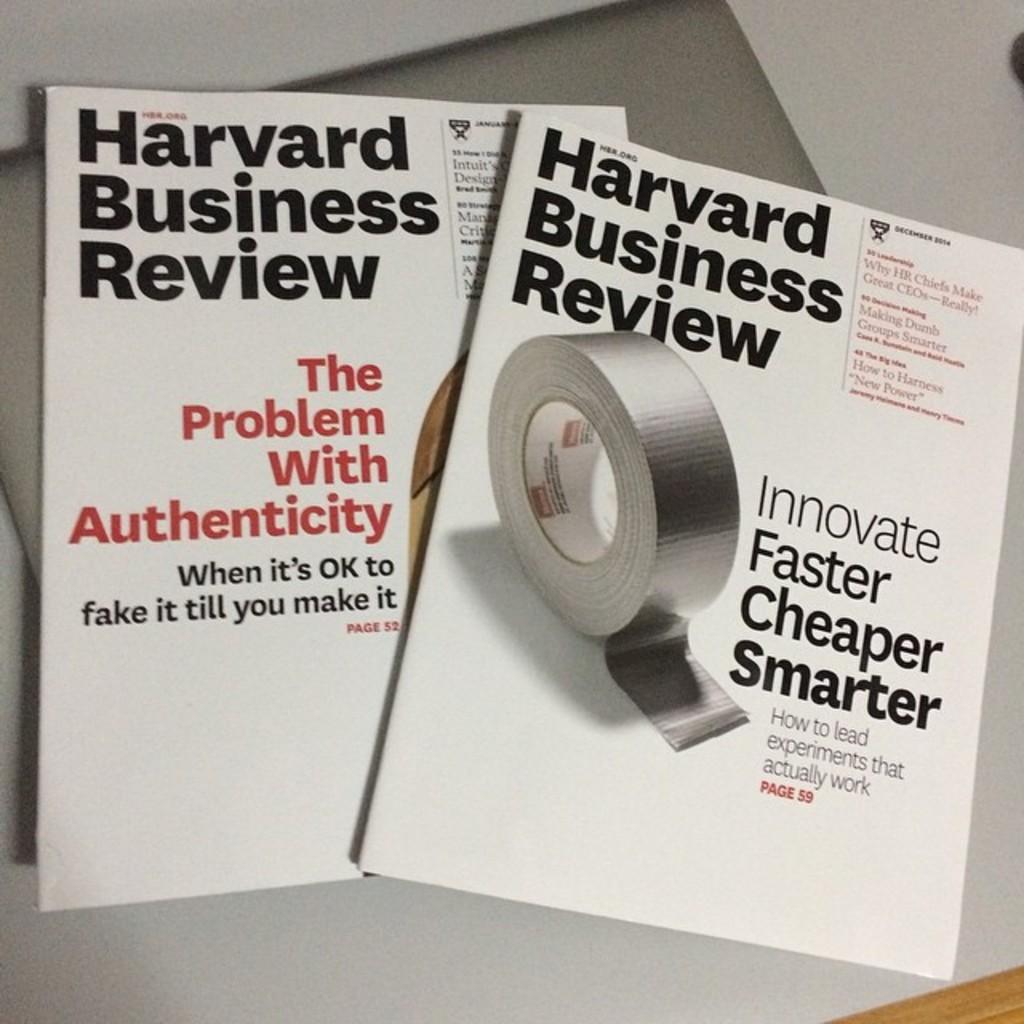What 3 ways can you innovate?
Give a very brief answer. Faster cheaper smarter. 